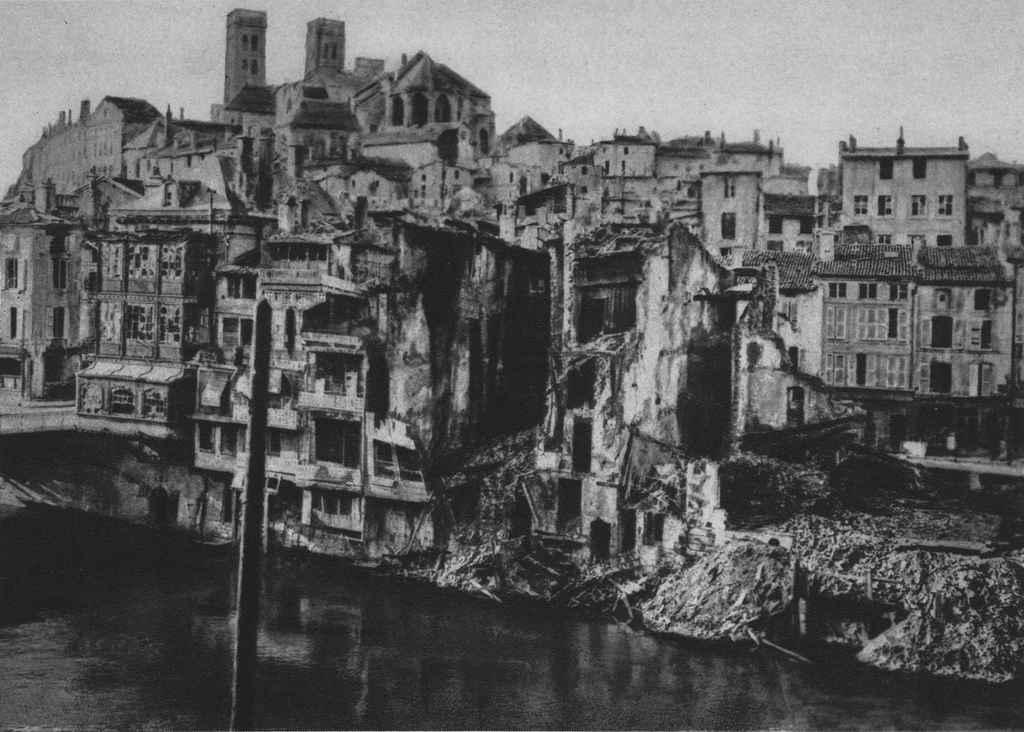What is present in the image that is not solid? There is water visible in the image. What type of structures can be seen in the background of the image? There are buildings in the background of the image. What part of the natural environment is visible in the image? The sky is visible in the background of the image. What color scheme is used in the image? The image is in black and white. What type of crate is floating on the water in the image? There is no crate present in the image; it only features water, buildings, and the sky. What is your opinion on the image? As an AI, I do not have personal opinions, but I can provide a factual description of the image based on the given facts. 